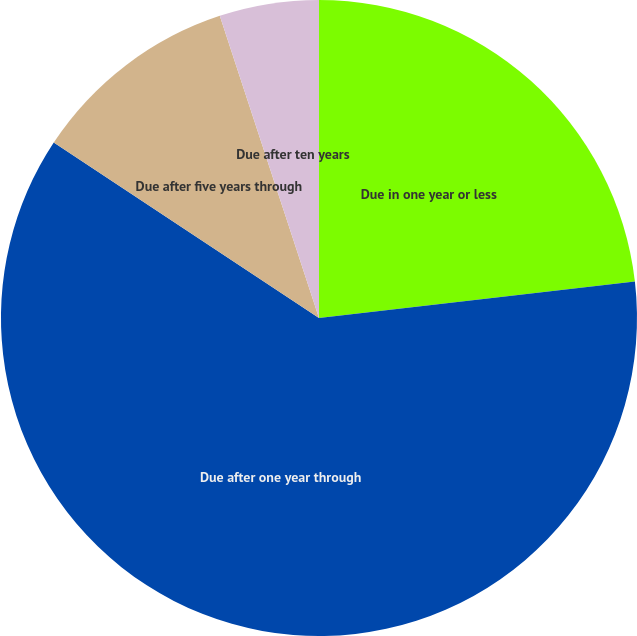Convert chart to OTSL. <chart><loc_0><loc_0><loc_500><loc_500><pie_chart><fcel>Due in one year or less<fcel>Due after one year through<fcel>Due after five years through<fcel>Due after ten years<nl><fcel>23.17%<fcel>61.13%<fcel>10.65%<fcel>5.05%<nl></chart> 